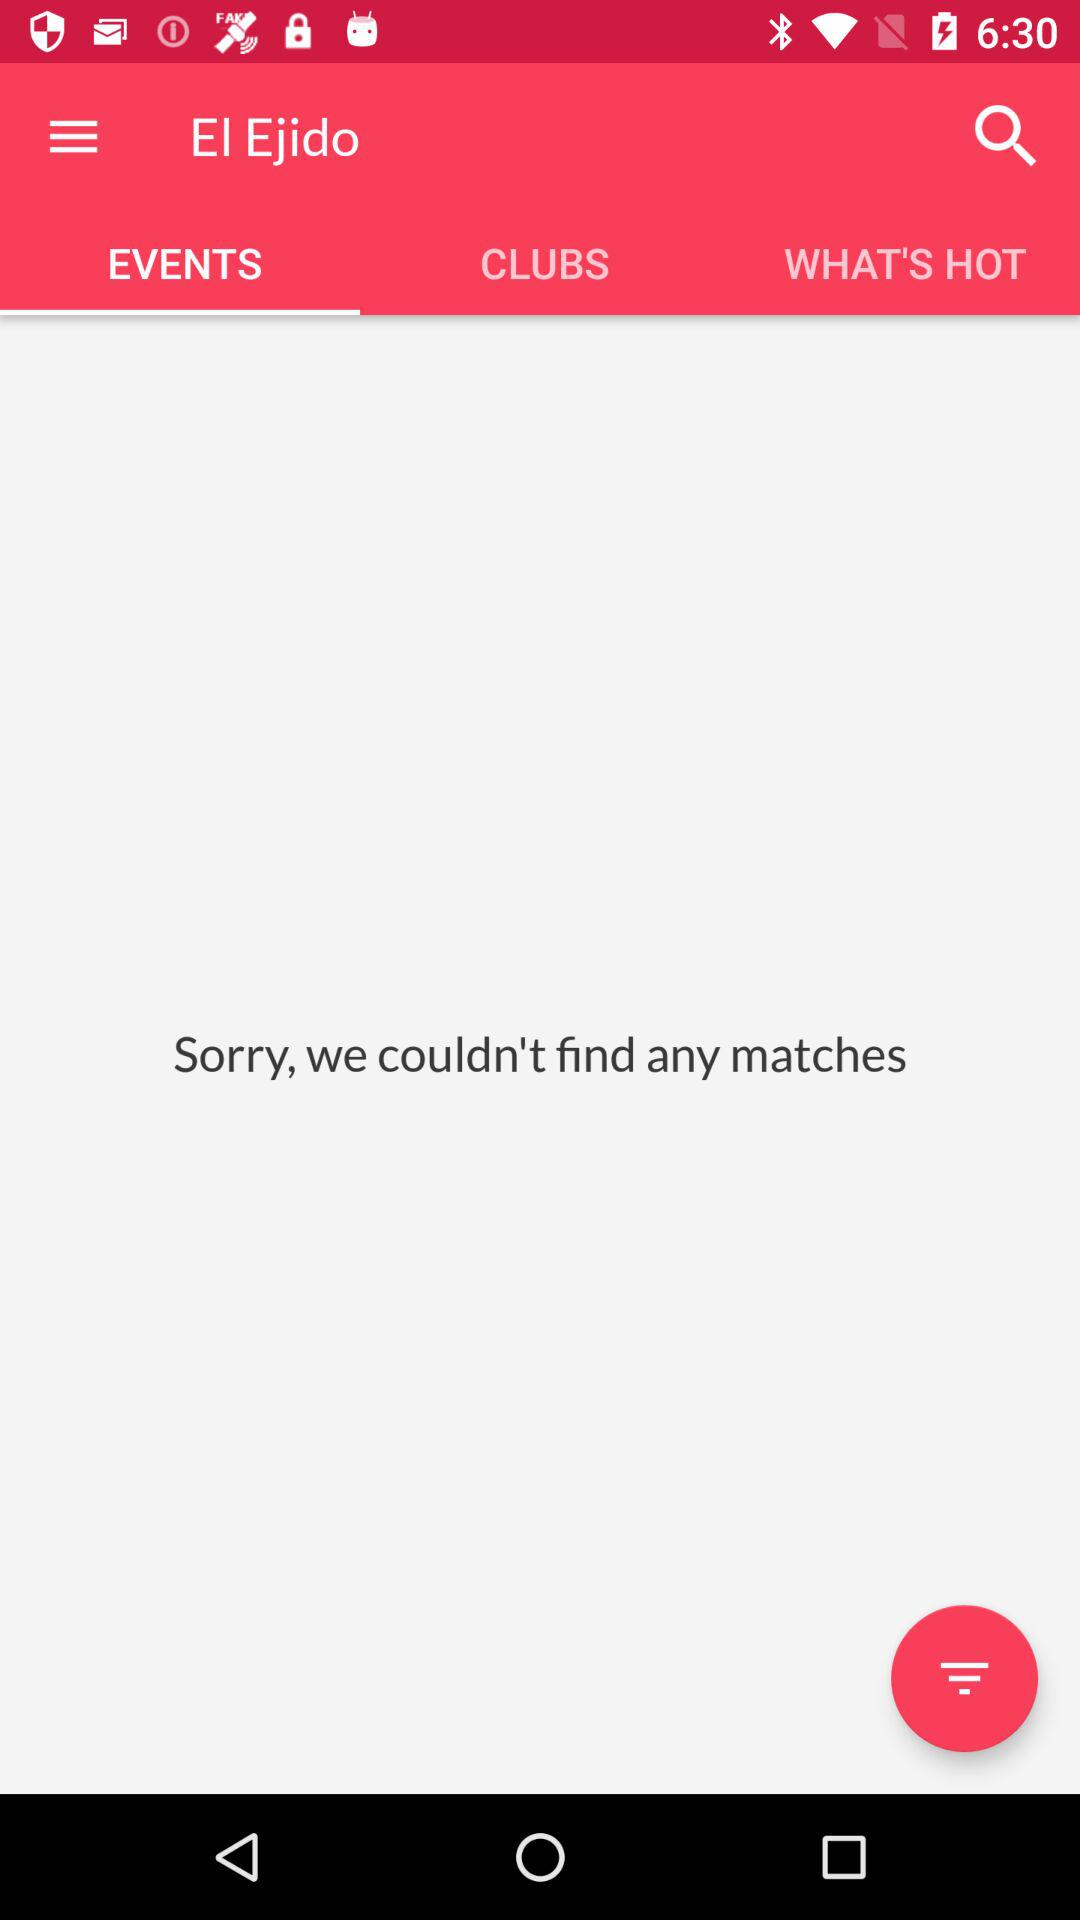Are there any matches?
When the provided information is insufficient, respond with <no answer>. <no answer> 